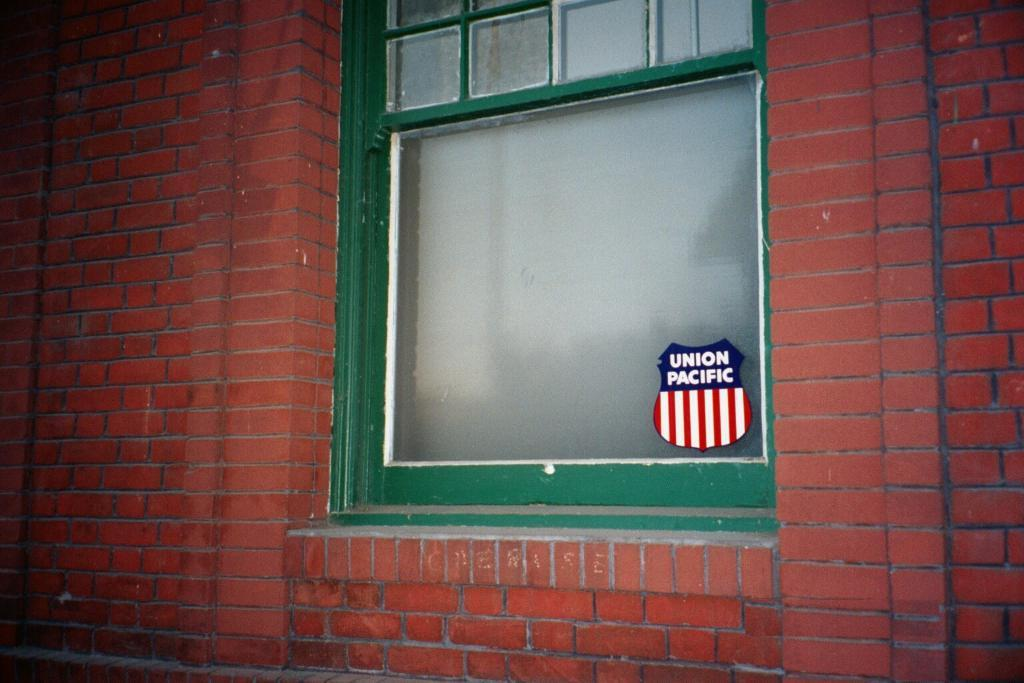<image>
Create a compact narrative representing the image presented. Union pacific sign that is in a green window of a building 